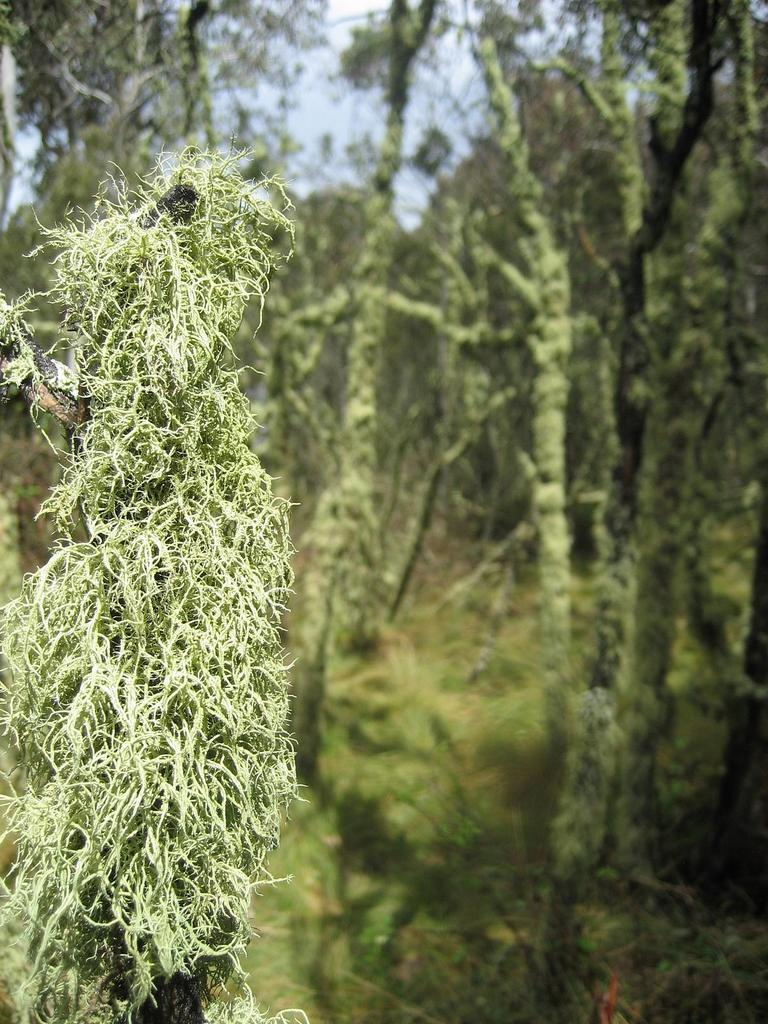What type of vegetation can be seen in the image? There are trees in the image. What color are the trees in the image? The trees are green in color. What can be seen in the background of the image? The sky is visible in the background of the image. What reason does the watch give for being late in the image? There is no watch present in the image, so it cannot provide a reason for being late. 